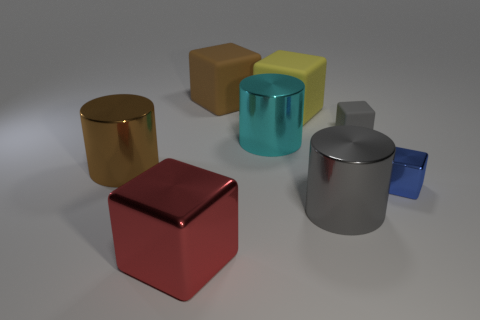Subtract all gray shiny cylinders. How many cylinders are left? 2 Subtract all red cubes. How many cubes are left? 4 Subtract 2 blocks. How many blocks are left? 3 Add 1 tiny gray blocks. How many objects exist? 9 Subtract all gray cubes. Subtract all gray balls. How many cubes are left? 4 Subtract all blocks. How many objects are left? 3 Subtract all brown metal blocks. Subtract all large cubes. How many objects are left? 5 Add 6 gray metal objects. How many gray metal objects are left? 7 Add 3 brown rubber things. How many brown rubber things exist? 4 Subtract 0 cyan cubes. How many objects are left? 8 